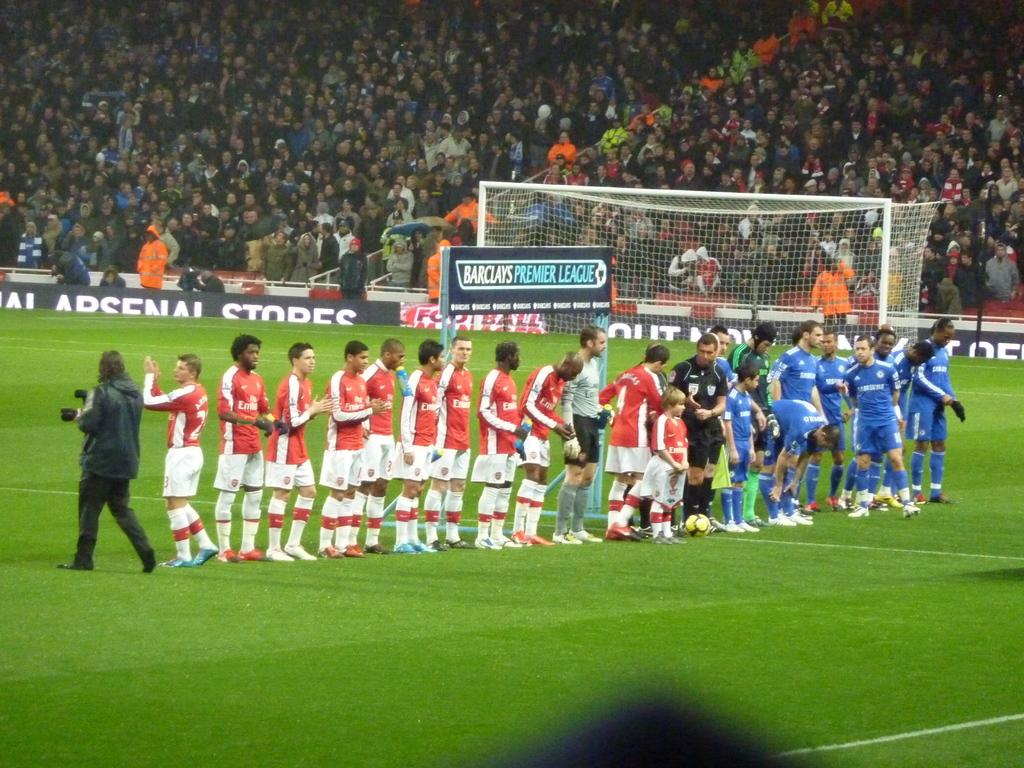<image>
Describe the image concisely. a groupd of two soccer teams from the premier league standing on the field 